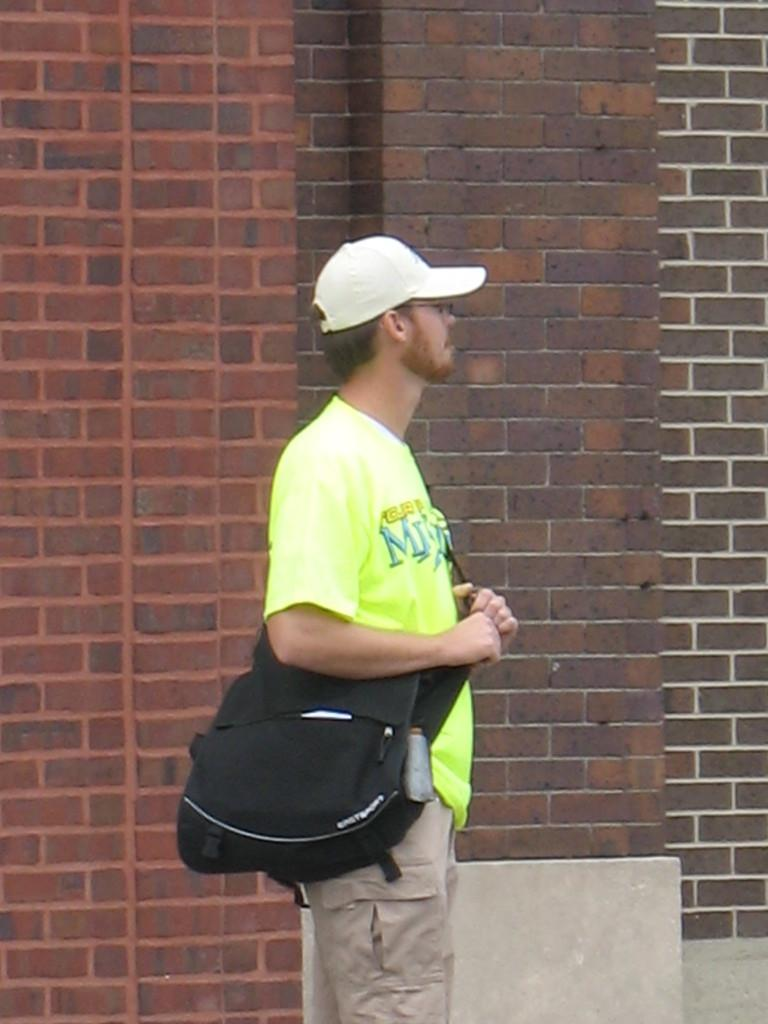What is the main subject in the foreground of the image? There is a man in the foreground of the image. What is the man doing in the image? The man is standing in the image. What is the man wearing on his body? The man is wearing a bag and a cap on his head. What can be seen in the background of the image? There is a brick wall in the background of the image. What color is the ink on the man's shirt in the image? There is no ink mentioned or visible on the man's shirt in the image. 